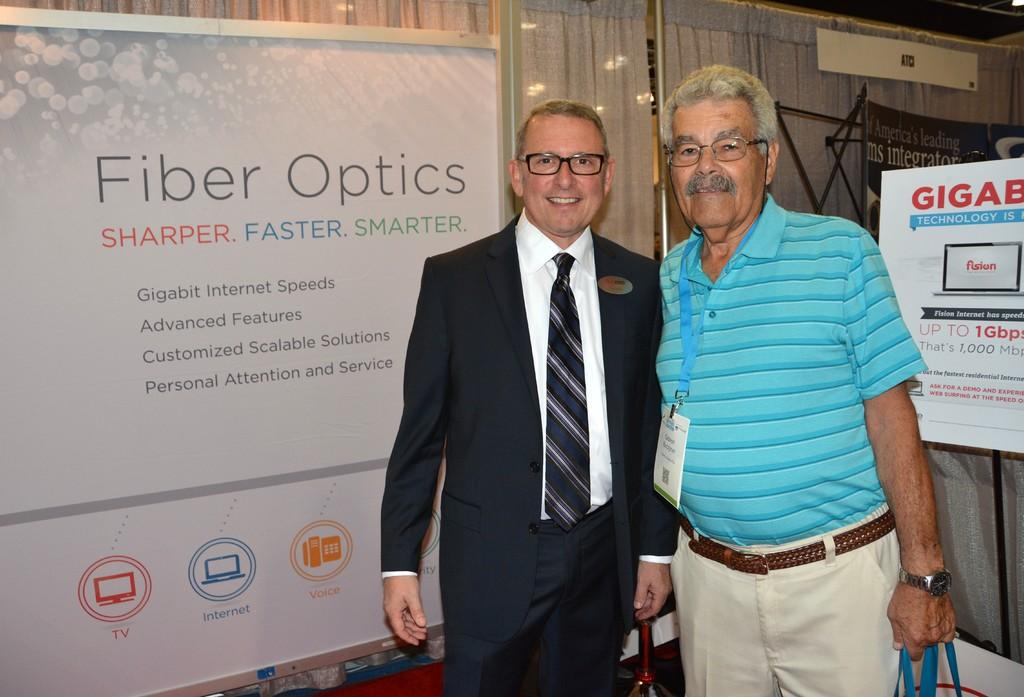How many people are in the image? There are two men in the image. What are the men doing in the image? The men are starting something. What can be seen in the background of the image? There is a curtain and boards in the background of the image. What is written or depicted on the boards? There is text on the boards. Can you see a basketball being played in the image? There is no basketball or any indication of a basketball game in the image. What country are the men from in the image? The country of origin for the men cannot be determined from the image. 